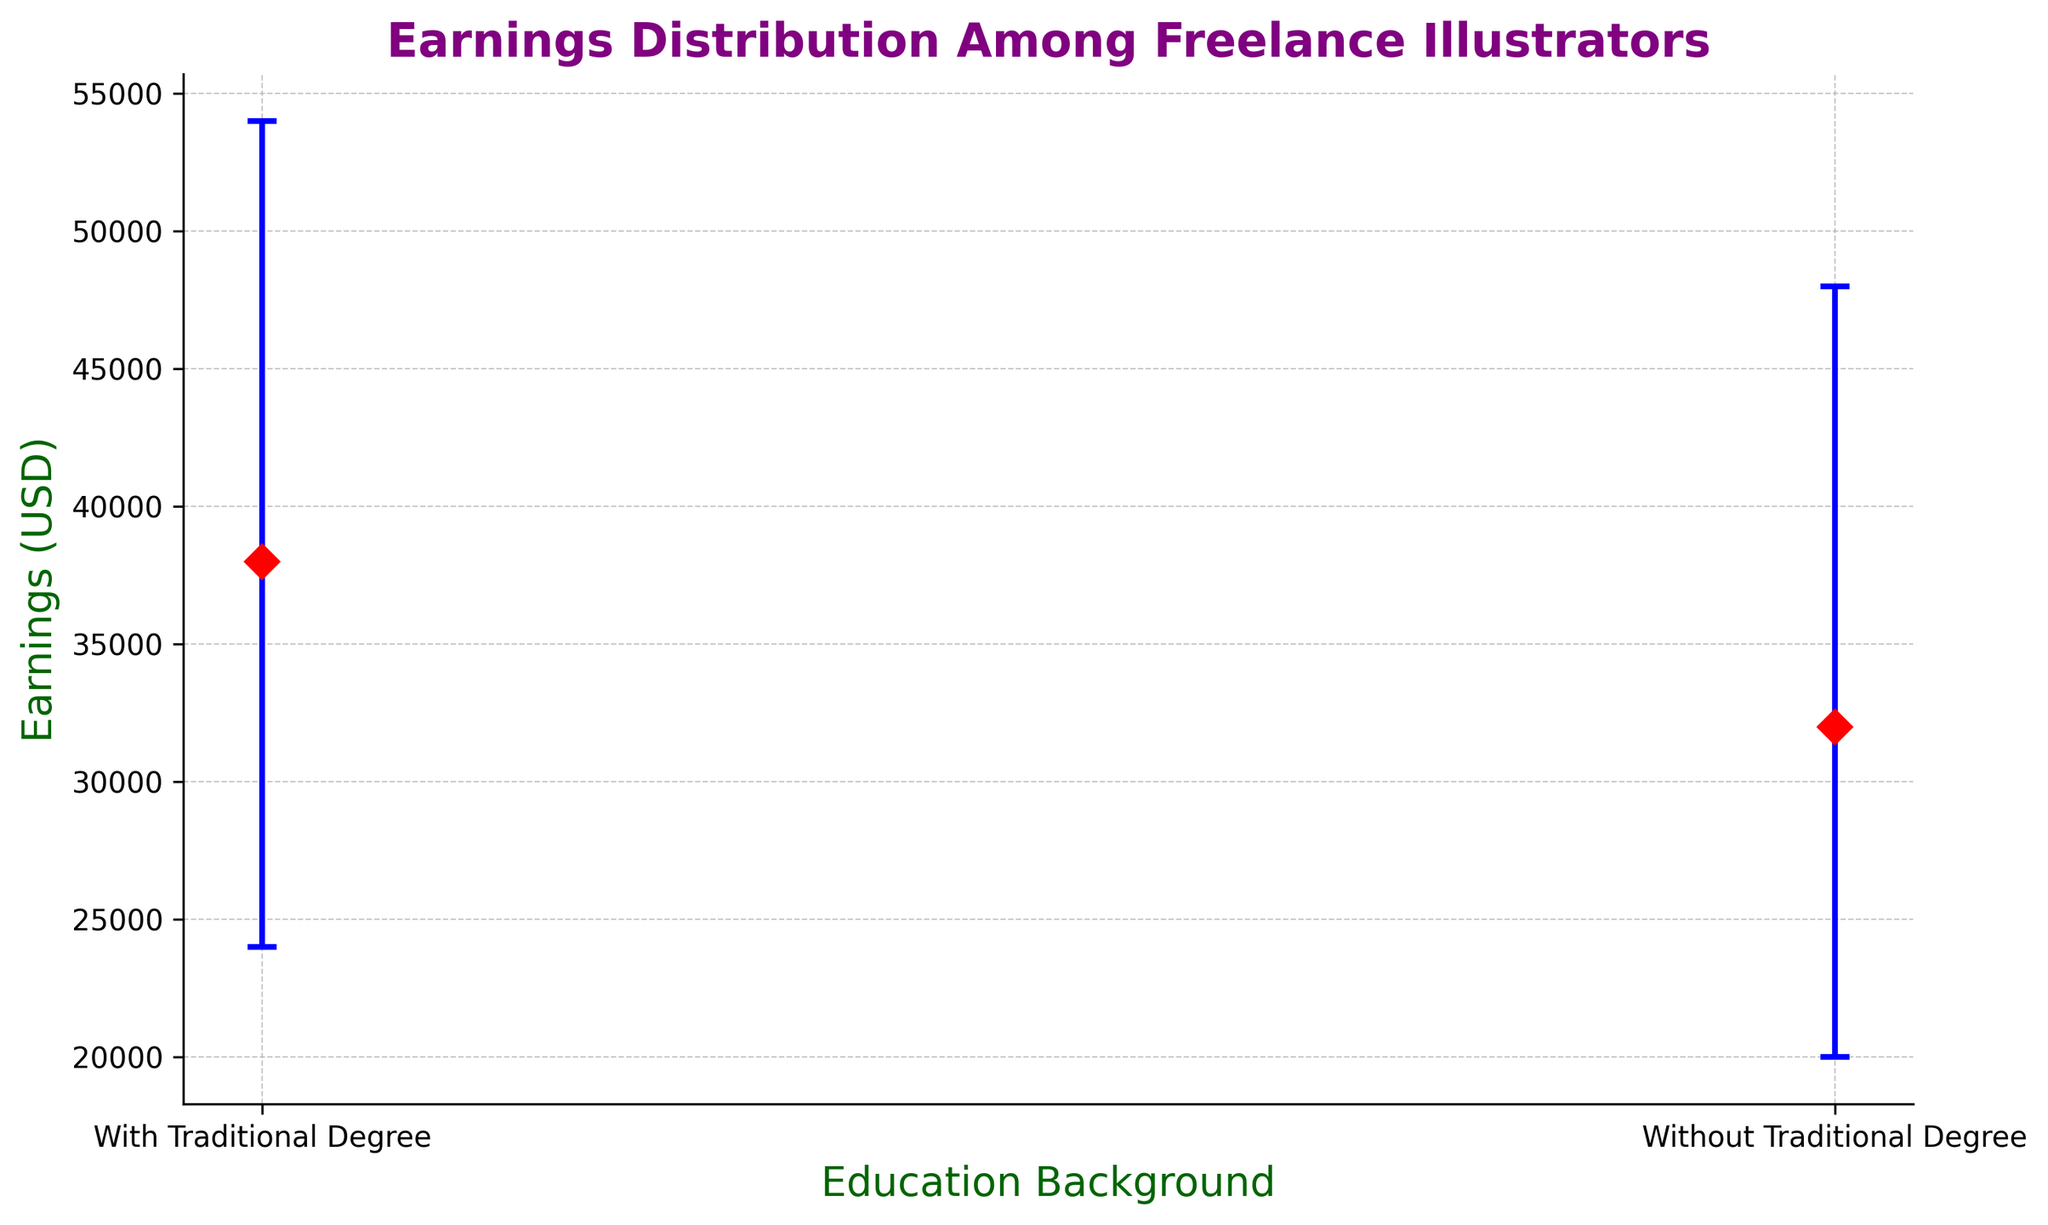What is the difference in median earnings between freelance illustrators with and without traditional degrees? To determine the difference in median earnings, subtract the median earnings of illustrators without traditional degrees from those with traditional degrees: 38000 - 32000 = 6000.
Answer: 6000 What are the earnings quartile ranges for freelance illustrators with traditional degrees? The lower quartile is 24000, and the upper quartile is 54000. The range can be calculated by subtracting the lower quartile from the upper quartile: 54000 - 24000 = 30000.
Answer: 30000 Which group has a wider interquartile range (IQR) of earnings? To compare the IQR for both groups, calculate the IQR for each. For illustrators with traditional degrees, IQR = 54000 - 24000 = 30000. For illustrators without traditional degrees, IQR = 48000 - 20000 = 28000. The group with the traditional degree has a wider IQR.
Answer: Freelance illustrators with traditional degrees How much lower is the median earning of illustrators without traditional degrees compared to the upper quartile of those with degrees? First, find the upper quartile for those with degrees, which is 54000. The median earning for those without degrees is 32000. Subtract the median from the upper quartile: 54000 - 32000 = 22000.
Answer: 22000 What is the error value range for the median earnings of illustrators with traditional degrees? Error bars indicate the spread around the median earnings value. With traditional degrees: lower error = 38000 - 24000 = 14000 and upper error = 54000 - 38000 = 16000, so the range is 14000 to 16000.
Answer: 14000 to 16000 What is the visual marker used to represent the median earnings for both groups? The visual marker used for the median earnings is a red diamond.
Answer: Red diamond Which group has a greater deviation between the median and the lower quartile? Calculate the deviation from the median to the lower quartile for each group. For those with degrees: 38000 - 24000 = 14000. For those without degrees: 32000 - 20000 = 12000. The group with traditional degrees has a greater deviation.
Answer: Freelance illustrators with traditional degrees Which group has a higher median earning? The median earnings for illustrators with traditional degrees is 38000, while it is 32000 for those without traditional degrees. Therefore, illustrators with traditional degrees have a higher median earning.
Answer: Freelance illustrators with traditional degrees 